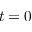<formula> <loc_0><loc_0><loc_500><loc_500>t = 0</formula> 